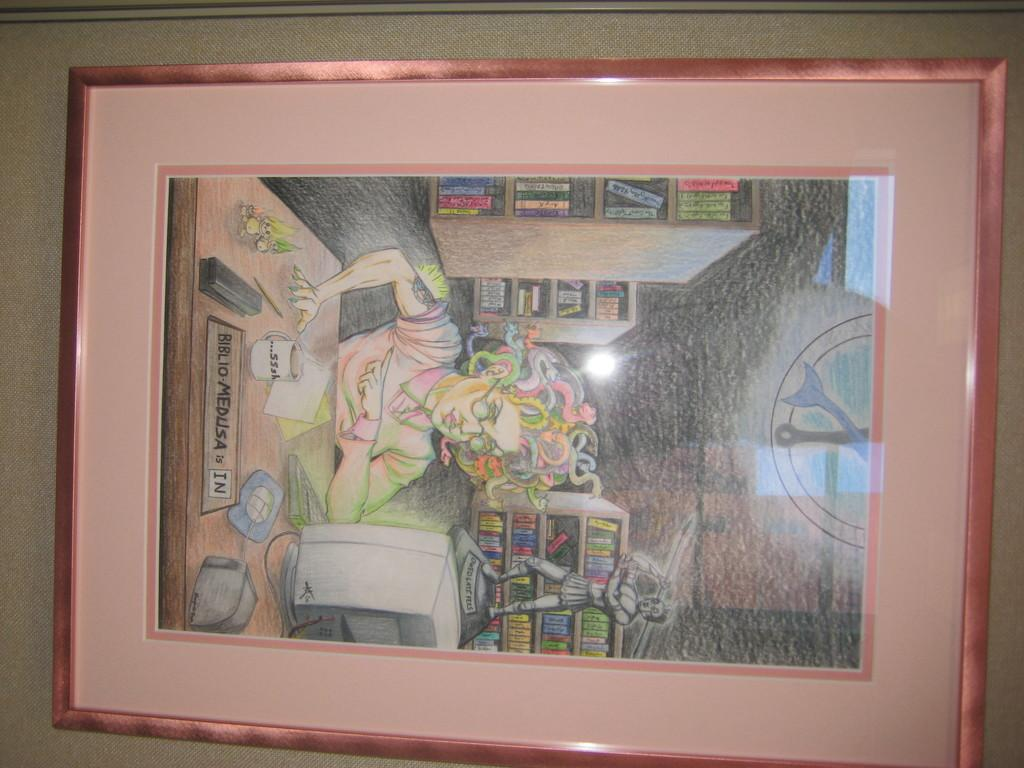What is on the wall in the image? There is a depiction on the wall in the image. What type of can is shown in the depiction on the wall? There is no can present in the depiction on the wall; it is not mentioned in the provided facts. 